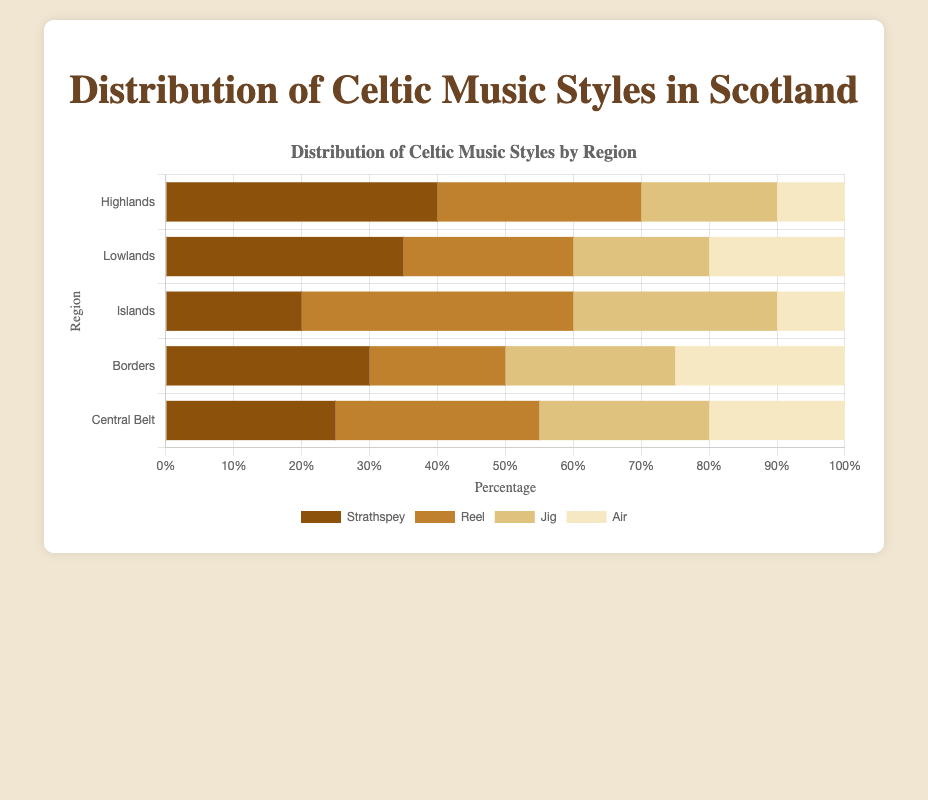Which region has the highest percentage of Strathspey? To determine which region has the highest percentage of Strathspey, compare the Strathspey values for all regions. The Highlands has 40%, Lowlands has 35%, Islands have 20%, Borders have 30%, and Central Belt has 25%. The highest percentage is 40% in the Highlands.
Answer: Highlands What is the total percentage of Jig for all regions combined? To find the total percentage of Jig for all regions, add the percentages: Highlands (20%) + Lowlands (20%) + Islands (30%) + Borders (25%) + Central Belt (25%). This sums to 120%.
Answer: 120% Which style has the lowest average percentage across all regions? Calculate the average percentage for each style: 
- Strathspey: (40% + 35% + 20% + 30% + 25%) / 5 = 30%
- Reel: (30% + 25% + 40% + 20% + 30%) / 5 = 29%
- Jig: (20% + 20% + 30% + 25% + 25%) / 5 = 24%
- Air: (10% + 20% + 10% + 25% + 20%) / 5 = 17%
The lowest average is for Air at 17%.
Answer: Air Which two regions have the same percentage for Air? Check the percentage of Air for each region and identify if any two regions have the same value. The Highlands has 10%, Lowlands has 20%, Islands have 10%, Borders have 25%, and Central Belt has 20%. The Highlands and Islands both have 10%, and the Lowlands and Central Belt both have 20%.
Answer: Highlands and Islands; Lowlands and Central Belt What is the difference in the percentage of Reels between the Highlands and the Islands? Subtract the percentage of Reels in the Highlands (30%) from the percentage in the Islands (40%). This gives a difference of 10%.
Answer: 10% Which regions have a higher percentage of Jigs than Strathspeys? Compare the percentages of Jigs and Strathspeys for each region:
- Highlands: Jig (20%) < Strathspey (40%)
- Lowlands: Jig (20%) < Strathspey (35%)
- Islands: Jig (30%) > Strathspey (20%)
- Borders: Jig (25%) < Strathspey (30%)
- Central Belt: Jig (25%) > Strathspey (25%)
The Islands and Central Belt have a higher percentage of Jigs than Strathspeys.
Answer: Islands and Central Belt Which style is most evenly distributed across all regions? Calculate the variance for each style:
- Strathspey: Variance = ((40-30)^2 + (35-30)^2 + (20-30)^2 + (30-30)^2 + (25-30)^2) / 5 = 46 / 5 = 9.2
- Reel: Variance = ((30-29)^2 + (25-29)^2 + (40-29)^2 + (20-29)^2 + (30-29)^2) / 5 = 86 / 5 = 17.2
- Jig: Variance = ((20-24)^2 + (20-24)^2 + (30-24)^2 + (25-24)^2 + (25-24)^2) / 5 = 60 / 5 = 12
- Air: Variance = ((10-17)^2 + (20-17)^2 + (10-17)^2 + (25-17)^2 + (20-17)^2) / 5 = 166 / 5 = 33.2
Strathspey has the lowest variance (9.2), indicating it is the most evenly distributed.
Answer: Strathspey 